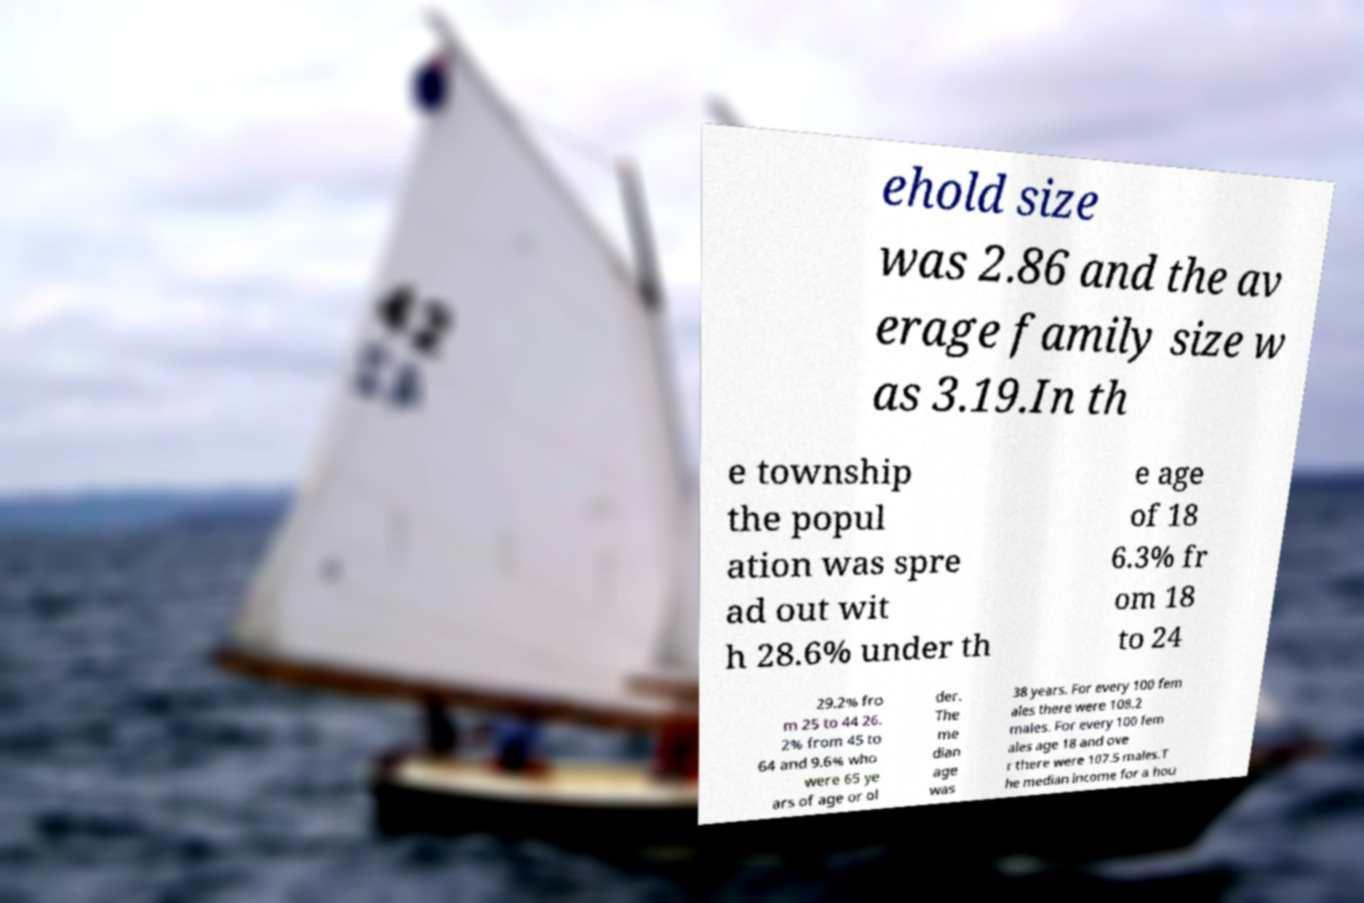Could you extract and type out the text from this image? ehold size was 2.86 and the av erage family size w as 3.19.In th e township the popul ation was spre ad out wit h 28.6% under th e age of 18 6.3% fr om 18 to 24 29.2% fro m 25 to 44 26. 2% from 45 to 64 and 9.6% who were 65 ye ars of age or ol der. The me dian age was 38 years. For every 100 fem ales there were 108.2 males. For every 100 fem ales age 18 and ove r there were 107.5 males.T he median income for a hou 